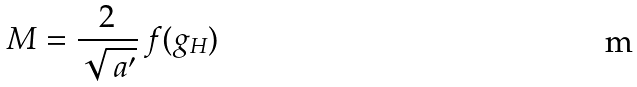<formula> <loc_0><loc_0><loc_500><loc_500>M = \frac { 2 } { \sqrt { \ a ^ { \prime } } } \, f ( g _ { H } )</formula> 